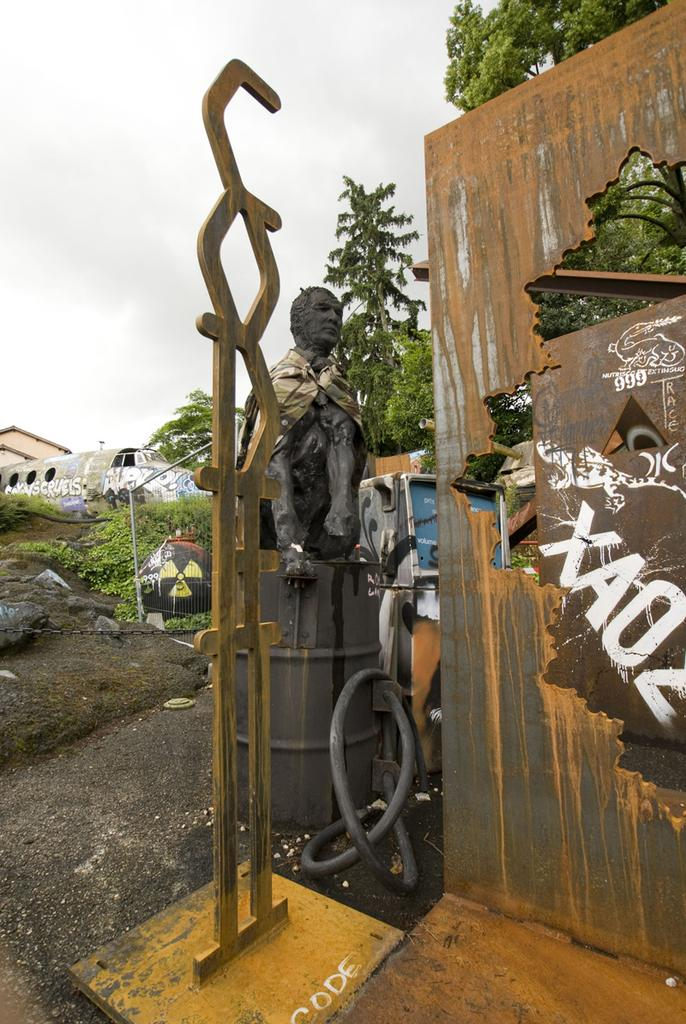What is the main subject in the front of the image? There is a statue in the front of the image. What else can be seen in the front of the image besides the statue? There are objects in the front of the image. What type of natural elements can be seen in the background of the image? There are trees and rocks in the background of the image. What man-made structures can be seen in the background of the image? There is a vehicle, a pole, and a chain in the background of the image. What is the condition of the sky in the background of the image? The sky is cloudy in the background of the image. Are there any additional objects in the background of the image? Yes, there are additional objects in the background of the image. How many houses are visible in the image? There are no houses visible in the image. What type of steel is used to construct the statue in the image? There is no information about the type of steel used to construct the statue in the image. 